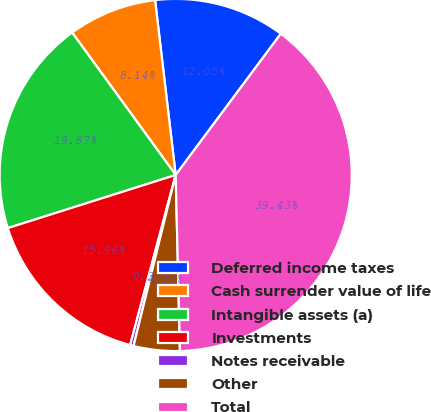Convert chart. <chart><loc_0><loc_0><loc_500><loc_500><pie_chart><fcel>Deferred income taxes<fcel>Cash surrender value of life<fcel>Intangible assets (a)<fcel>Investments<fcel>Notes receivable<fcel>Other<fcel>Total<nl><fcel>12.05%<fcel>8.14%<fcel>19.87%<fcel>15.96%<fcel>0.32%<fcel>4.23%<fcel>39.43%<nl></chart> 